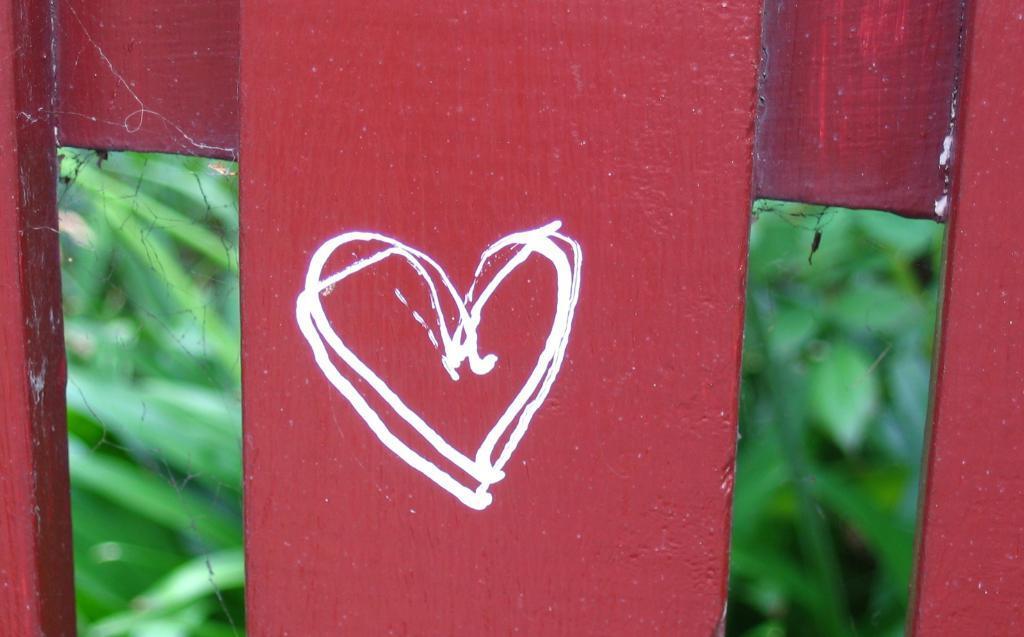Please provide a concise description of this image. In this image, in the foreground we can see heart shape drawing on the wood. 